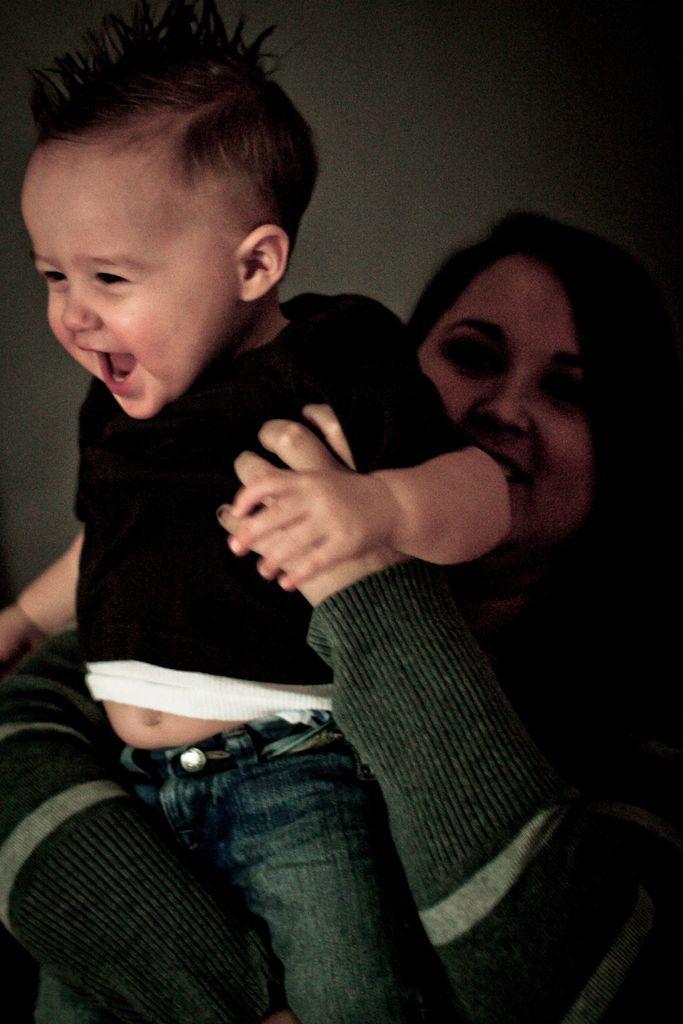Can you describe this image briefly? In this image we can see a lady holding a baby. In the back there is a wall. 